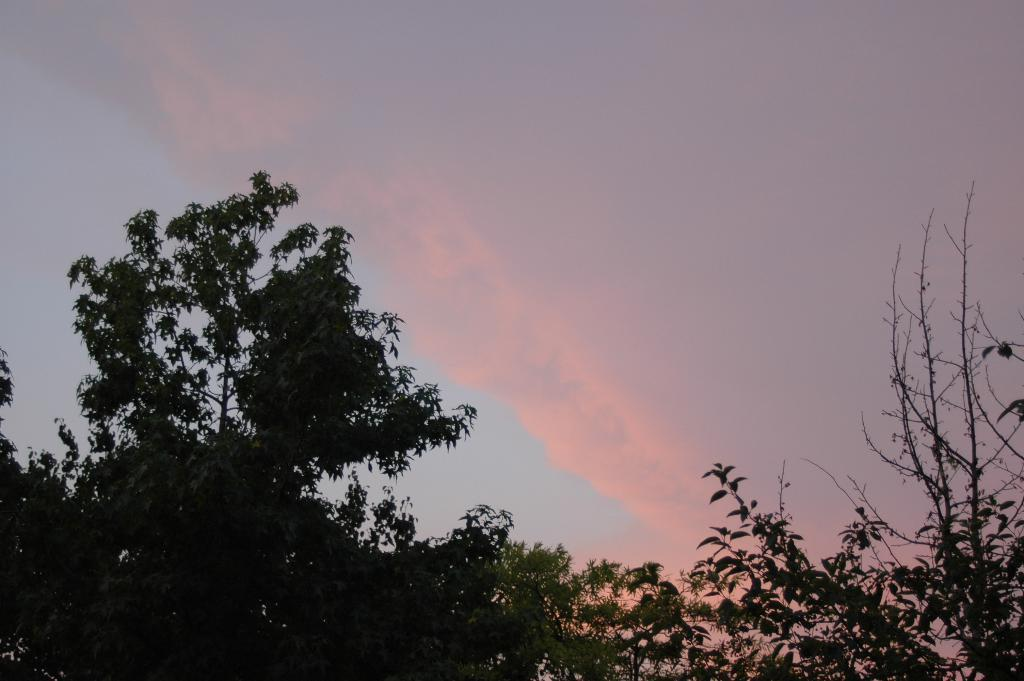What type of vegetation can be seen in the image? There are trees in the image. What part of the trees is visible in the image? There are branches in the image. What is visible in the background of the image? The sky is visible in the background of the image. How would you describe the weather based on the sky in the image? The sky appears to be cloudy in the image. What type of glue is being used to hold the meeting in the image? There is no meeting or glue present in the image. The image features trees and a cloudy sky. 